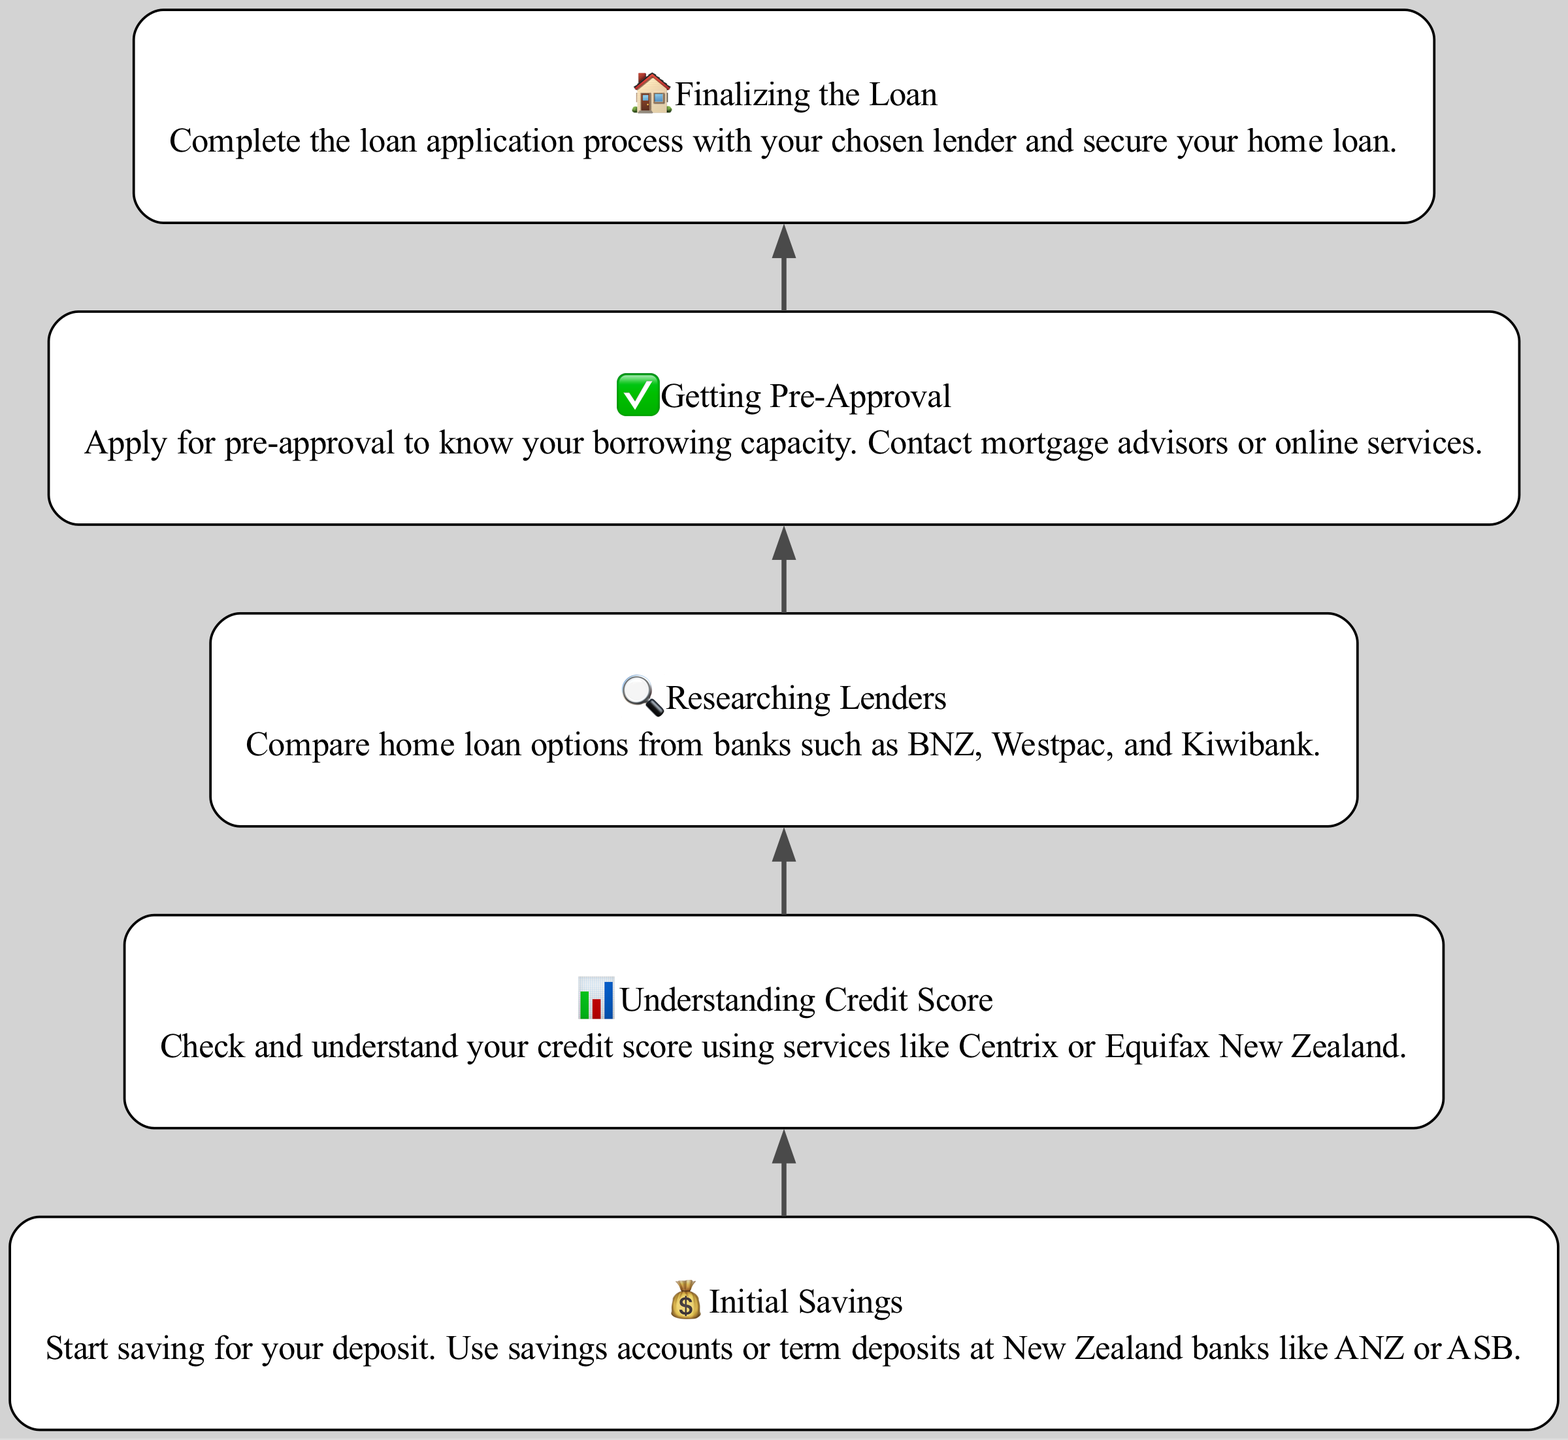What is the first step in securing a home loan? The diagram shows that "Initial Savings" is the first step depicted at the bottom of the flowchart, indicating it is where the process begins.
Answer: Initial Savings How many total steps are listed in the diagram? The diagram contains five distinct steps, each represented as a node in the flowchart.
Answer: 5 What icon represents 'Understanding Credit Score'? The diagram indicates a bar chart icon (📊) associated with the 'Understanding Credit Score' step.
Answer: 📊 Which step comes after 'Researching Lenders'? According to the flow in the diagram, the step that follows 'Researching Lenders' is 'Getting Pre-Approval'.
Answer: Getting Pre-Approval What is the last step in the home loan process? Following the directional flow from bottom to top in the diagram, 'Finalizing the Loan' is the last step indicated at the top.
Answer: Finalizing the Loan What is recommended for building 'Initial Savings'? The diagram suggests that saving for your deposit can be achieved through savings accounts or term deposits at banks like ANZ or ASB, mentioned in the description under the 'Initial Savings' node.
Answer: Savings accounts or term deposits How does one verify their credit score according to the diagram? The diagram recommends using services like Centrix or Equifax New Zealand to check and understand one's credit score, as indicated in the description for 'Understanding Credit Score'.
Answer: Centrix or Equifax New Zealand Which step is directly before 'Finalizing the Loan'? The step that is immediately prior to 'Finalizing the Loan' in the flowchart is 'Getting Pre-Approval', showing the progression needed to reach the final step.
Answer: Getting Pre-Approval Why is 'Getting Pre-Approval' important in the home loan process? The diagram states that 'Getting Pre-Approval' is crucial to know your borrowing capacity, highlighting its significance in the home loan process.
Answer: To know your borrowing capacity 